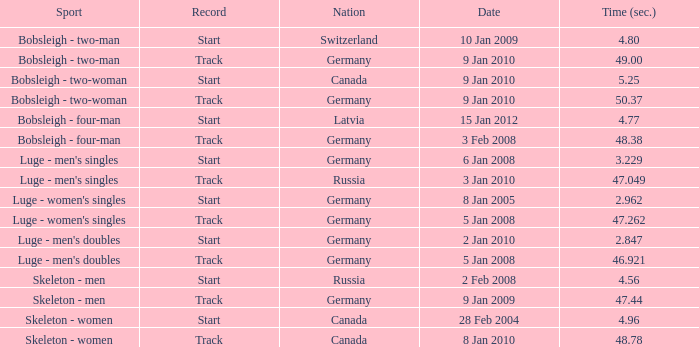Which country recorded a time of 48.38? Germany. Could you parse the entire table? {'header': ['Sport', 'Record', 'Nation', 'Date', 'Time (sec.)'], 'rows': [['Bobsleigh - two-man', 'Start', 'Switzerland', '10 Jan 2009', '4.80'], ['Bobsleigh - two-man', 'Track', 'Germany', '9 Jan 2010', '49.00'], ['Bobsleigh - two-woman', 'Start', 'Canada', '9 Jan 2010', '5.25'], ['Bobsleigh - two-woman', 'Track', 'Germany', '9 Jan 2010', '50.37'], ['Bobsleigh - four-man', 'Start', 'Latvia', '15 Jan 2012', '4.77'], ['Bobsleigh - four-man', 'Track', 'Germany', '3 Feb 2008', '48.38'], ["Luge - men's singles", 'Start', 'Germany', '6 Jan 2008', '3.229'], ["Luge - men's singles", 'Track', 'Russia', '3 Jan 2010', '47.049'], ["Luge - women's singles", 'Start', 'Germany', '8 Jan 2005', '2.962'], ["Luge - women's singles", 'Track', 'Germany', '5 Jan 2008', '47.262'], ["Luge - men's doubles", 'Start', 'Germany', '2 Jan 2010', '2.847'], ["Luge - men's doubles", 'Track', 'Germany', '5 Jan 2008', '46.921'], ['Skeleton - men', 'Start', 'Russia', '2 Feb 2008', '4.56'], ['Skeleton - men', 'Track', 'Germany', '9 Jan 2009', '47.44'], ['Skeleton - women', 'Start', 'Canada', '28 Feb 2004', '4.96'], ['Skeleton - women', 'Track', 'Canada', '8 Jan 2010', '48.78']]} 